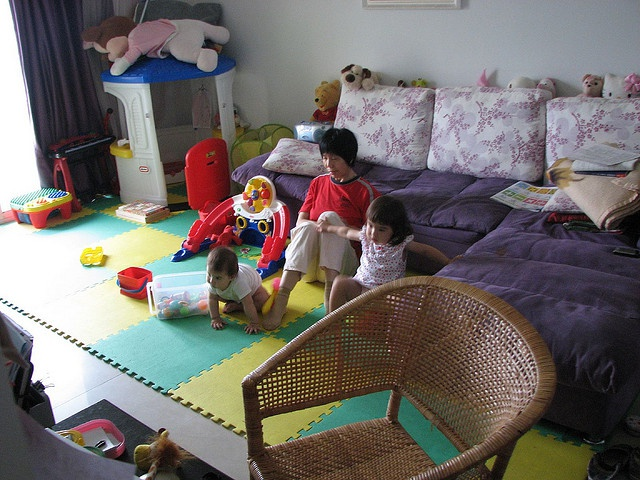Describe the objects in this image and their specific colors. I can see couch in white, black, darkgray, and gray tones, chair in white, maroon, black, and gray tones, people in white, maroon, black, and gray tones, people in white, black, gray, maroon, and darkgray tones, and people in white, black, gray, and maroon tones in this image. 